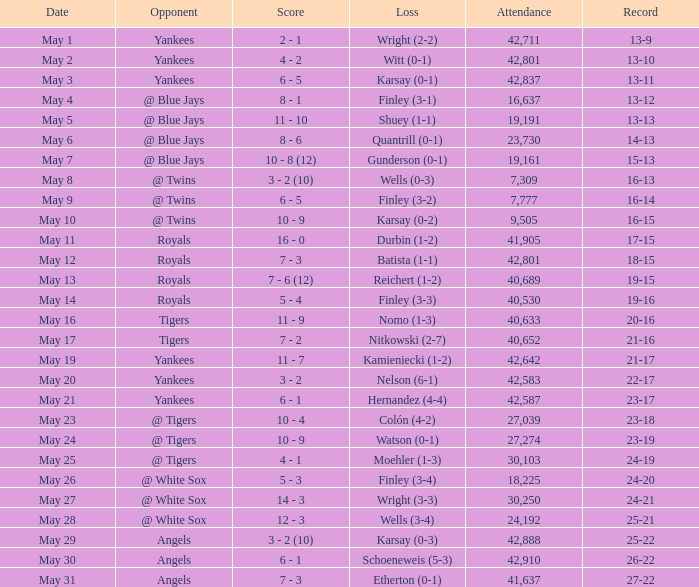What is the attendance for the game on May 25? 30103.0. 